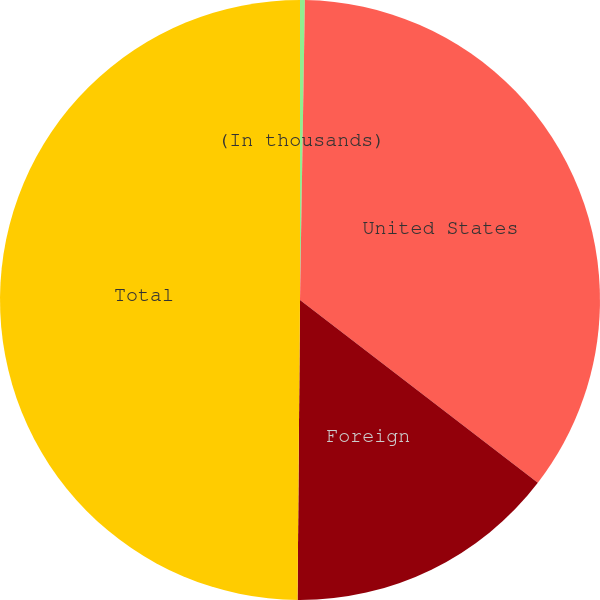Convert chart. <chart><loc_0><loc_0><loc_500><loc_500><pie_chart><fcel>(In thousands)<fcel>United States<fcel>Foreign<fcel>Total<nl><fcel>0.26%<fcel>35.17%<fcel>14.7%<fcel>49.87%<nl></chart> 